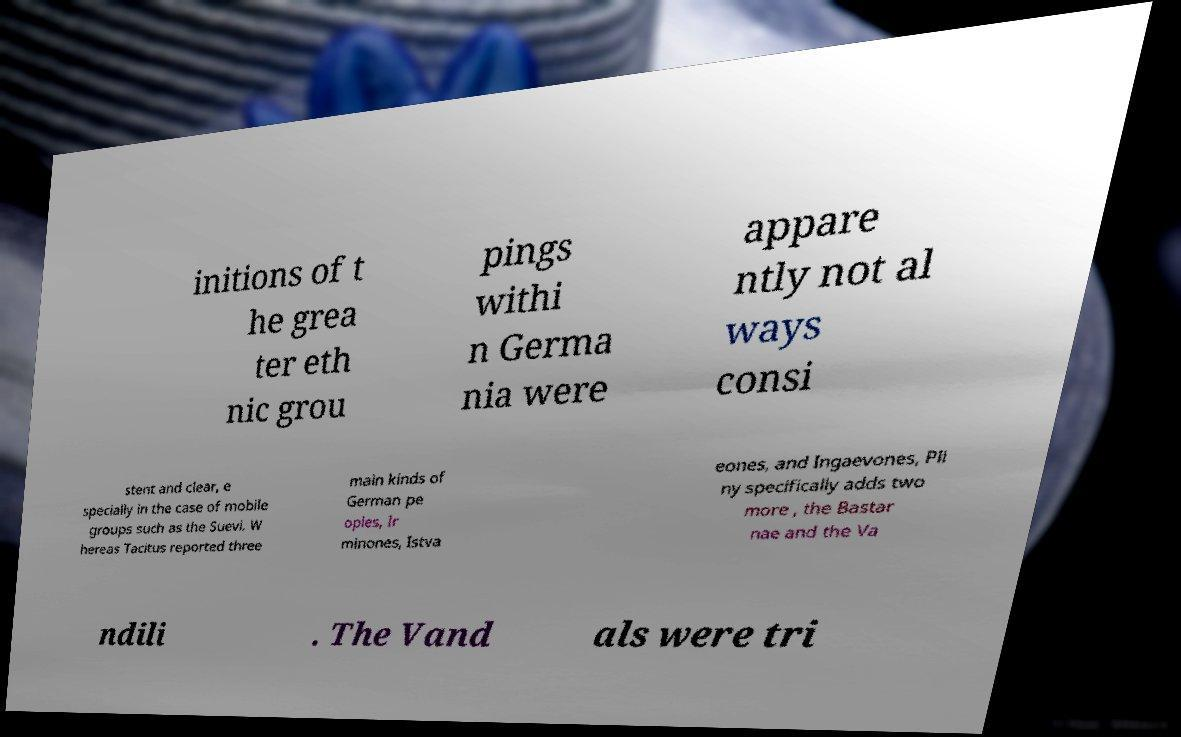For documentation purposes, I need the text within this image transcribed. Could you provide that? initions of t he grea ter eth nic grou pings withi n Germa nia were appare ntly not al ways consi stent and clear, e specially in the case of mobile groups such as the Suevi. W hereas Tacitus reported three main kinds of German pe oples, Ir minones, Istva eones, and Ingaevones, Pli ny specifically adds two more , the Bastar nae and the Va ndili . The Vand als were tri 